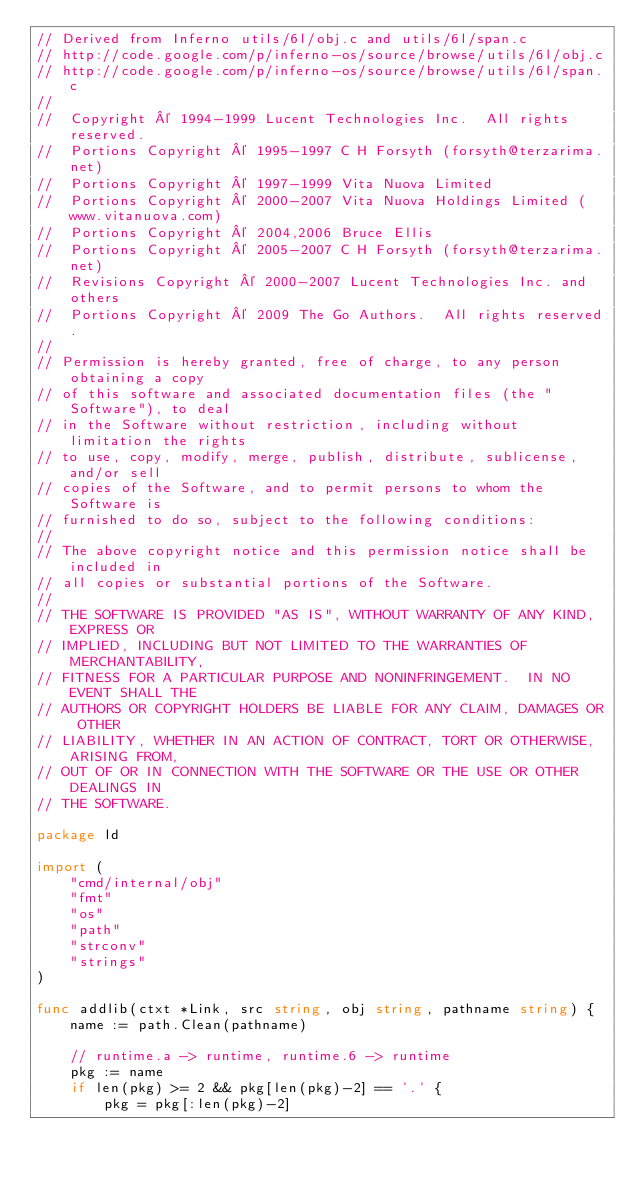Convert code to text. <code><loc_0><loc_0><loc_500><loc_500><_Go_>// Derived from Inferno utils/6l/obj.c and utils/6l/span.c
// http://code.google.com/p/inferno-os/source/browse/utils/6l/obj.c
// http://code.google.com/p/inferno-os/source/browse/utils/6l/span.c
//
//	Copyright © 1994-1999 Lucent Technologies Inc.  All rights reserved.
//	Portions Copyright © 1995-1997 C H Forsyth (forsyth@terzarima.net)
//	Portions Copyright © 1997-1999 Vita Nuova Limited
//	Portions Copyright © 2000-2007 Vita Nuova Holdings Limited (www.vitanuova.com)
//	Portions Copyright © 2004,2006 Bruce Ellis
//	Portions Copyright © 2005-2007 C H Forsyth (forsyth@terzarima.net)
//	Revisions Copyright © 2000-2007 Lucent Technologies Inc. and others
//	Portions Copyright © 2009 The Go Authors.  All rights reserved.
//
// Permission is hereby granted, free of charge, to any person obtaining a copy
// of this software and associated documentation files (the "Software"), to deal
// in the Software without restriction, including without limitation the rights
// to use, copy, modify, merge, publish, distribute, sublicense, and/or sell
// copies of the Software, and to permit persons to whom the Software is
// furnished to do so, subject to the following conditions:
//
// The above copyright notice and this permission notice shall be included in
// all copies or substantial portions of the Software.
//
// THE SOFTWARE IS PROVIDED "AS IS", WITHOUT WARRANTY OF ANY KIND, EXPRESS OR
// IMPLIED, INCLUDING BUT NOT LIMITED TO THE WARRANTIES OF MERCHANTABILITY,
// FITNESS FOR A PARTICULAR PURPOSE AND NONINFRINGEMENT.  IN NO EVENT SHALL THE
// AUTHORS OR COPYRIGHT HOLDERS BE LIABLE FOR ANY CLAIM, DAMAGES OR OTHER
// LIABILITY, WHETHER IN AN ACTION OF CONTRACT, TORT OR OTHERWISE, ARISING FROM,
// OUT OF OR IN CONNECTION WITH THE SOFTWARE OR THE USE OR OTHER DEALINGS IN
// THE SOFTWARE.

package ld

import (
	"cmd/internal/obj"
	"fmt"
	"os"
	"path"
	"strconv"
	"strings"
)

func addlib(ctxt *Link, src string, obj string, pathname string) {
	name := path.Clean(pathname)

	// runtime.a -> runtime, runtime.6 -> runtime
	pkg := name
	if len(pkg) >= 2 && pkg[len(pkg)-2] == '.' {
		pkg = pkg[:len(pkg)-2]</code> 